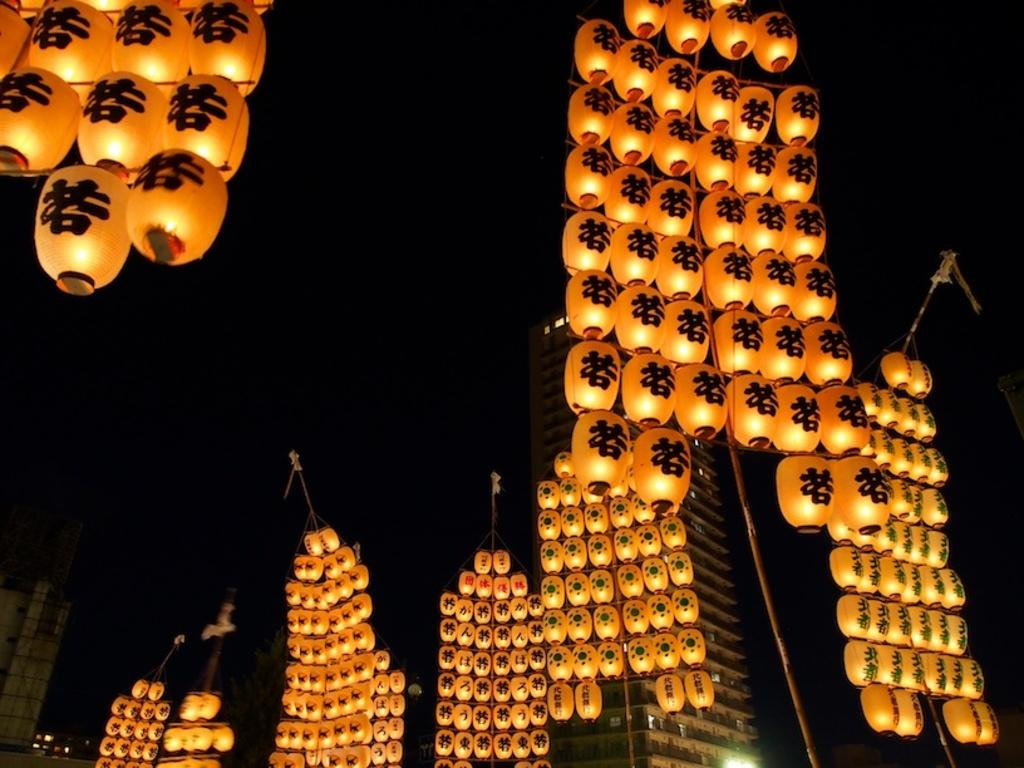What objects are present in the image that provide illumination? There are lanterns in the image that provide illumination. How are the lanterns positioned in the image? The lanterns are on stands in the image. What type of structures can be seen in the image? There are buildings visible in the image. What type of lighting is present in the image? There are lights in the image. How would you describe the overall lighting conditions in the image? The background of the image is dark. What is the price of the lunch served in the alley in the image? There is no lunch or alley present in the image; it features lanterns on stands, buildings, lights, and a dark background. 